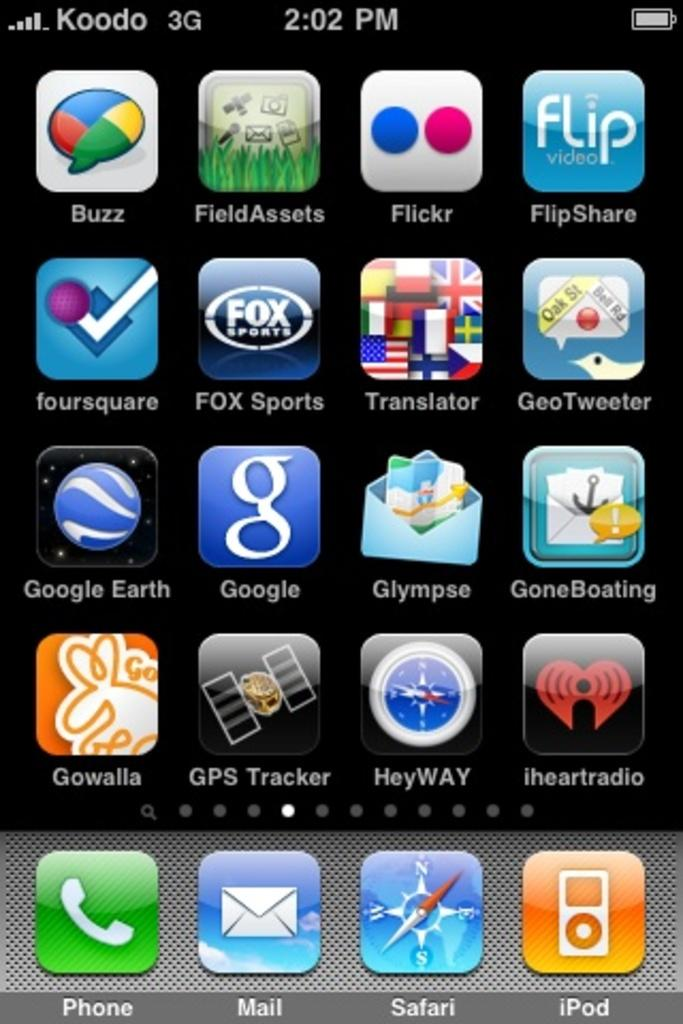<image>
Write a terse but informative summary of the picture. A Koodo brand phone offers 3G service at 2:02 PM. 